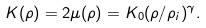Convert formula to latex. <formula><loc_0><loc_0><loc_500><loc_500>K ( \rho ) = 2 \mu ( \rho ) = K _ { 0 } ( \rho / \rho _ { i } ) ^ { \gamma } .</formula> 